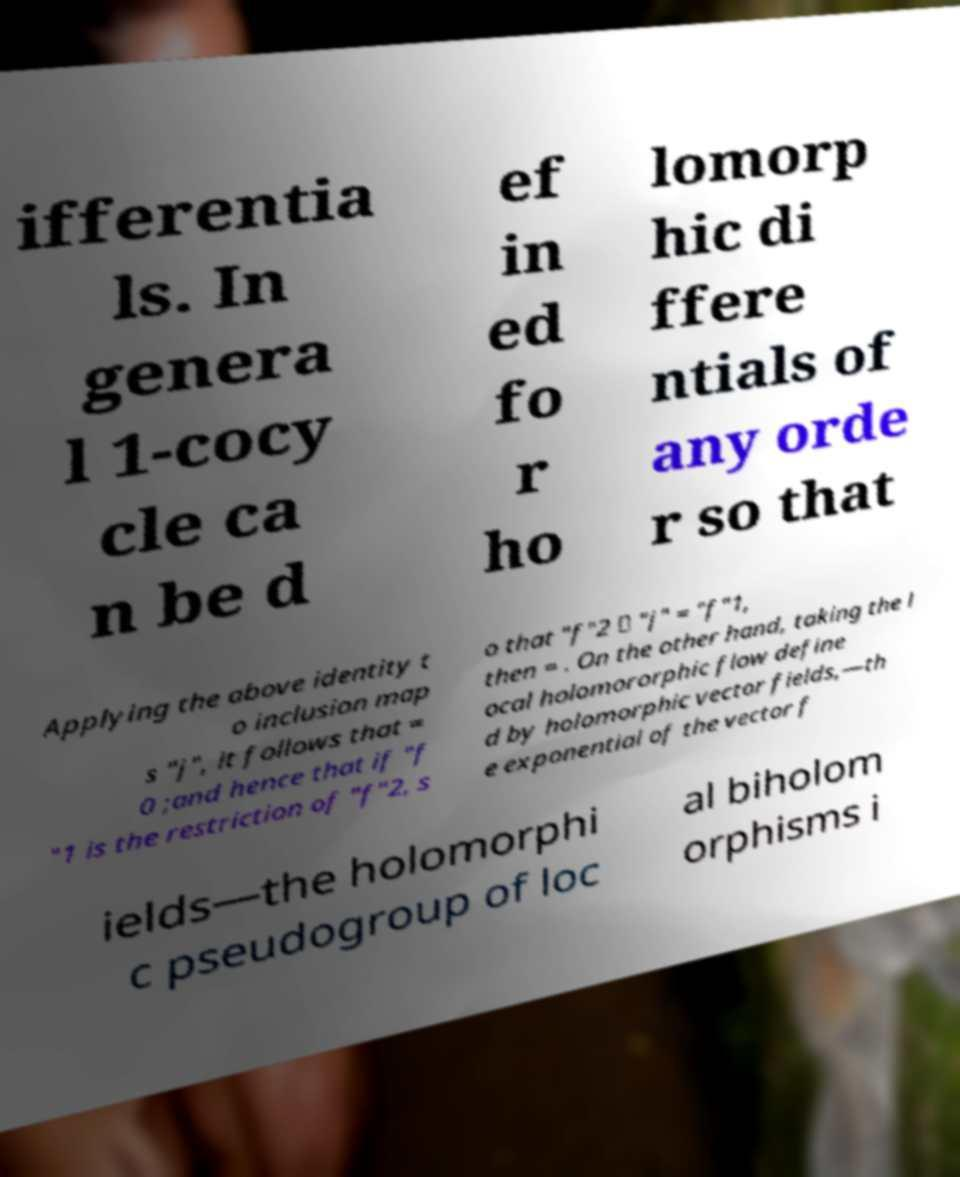For documentation purposes, I need the text within this image transcribed. Could you provide that? ifferentia ls. In genera l 1-cocy cle ca n be d ef in ed fo r ho lomorp hic di ffere ntials of any orde r so that Applying the above identity t o inclusion map s "j", it follows that = 0 ;and hence that if "f "1 is the restriction of "f"2, s o that "f"2 ∘ "j" = "f"1, then = . On the other hand, taking the l ocal holomororphic flow define d by holomorphic vector fields,—th e exponential of the vector f ields—the holomorphi c pseudogroup of loc al biholom orphisms i 